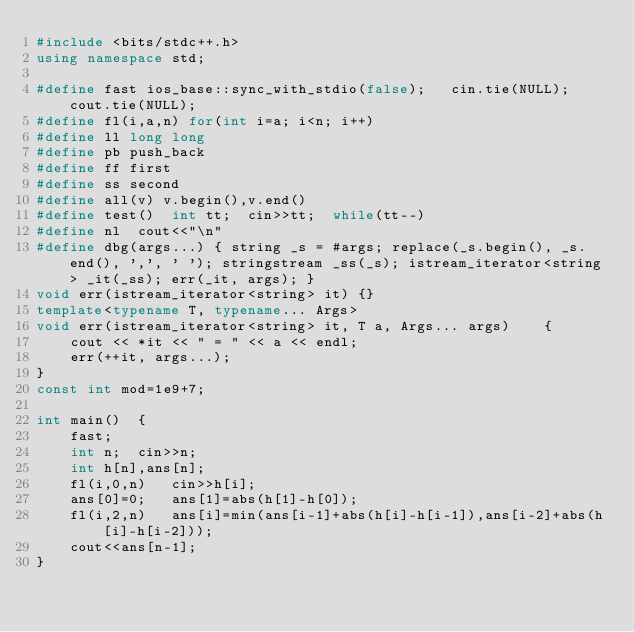Convert code to text. <code><loc_0><loc_0><loc_500><loc_500><_C++_>#include <bits/stdc++.h>
using namespace std;

#define fast ios_base::sync_with_stdio(false);   cin.tie(NULL); cout.tie(NULL);
#define fl(i,a,n) for(int i=a; i<n; i++)
#define ll long long 
#define pb push_back
#define ff first
#define ss second
#define all(v) v.begin(),v.end()
#define test()  int tt;  cin>>tt;  while(tt--)
#define nl  cout<<"\n"
#define dbg(args...) { string _s = #args; replace(_s.begin(), _s.end(), ',', ' '); stringstream _ss(_s); istream_iterator<string> _it(_ss); err(_it, args); }
void err(istream_iterator<string> it) {}
template<typename T, typename... Args>
void err(istream_iterator<string> it, T a, Args... args)    {
    cout << *it << " = " << a << endl;
    err(++it, args...);
}
const int mod=1e9+7;

int main()  {
    fast;
    int n;  cin>>n;
    int h[n],ans[n];
    fl(i,0,n)   cin>>h[i];
    ans[0]=0;   ans[1]=abs(h[1]-h[0]);
    fl(i,2,n)   ans[i]=min(ans[i-1]+abs(h[i]-h[i-1]),ans[i-2]+abs(h[i]-h[i-2]));
    cout<<ans[n-1];
}</code> 